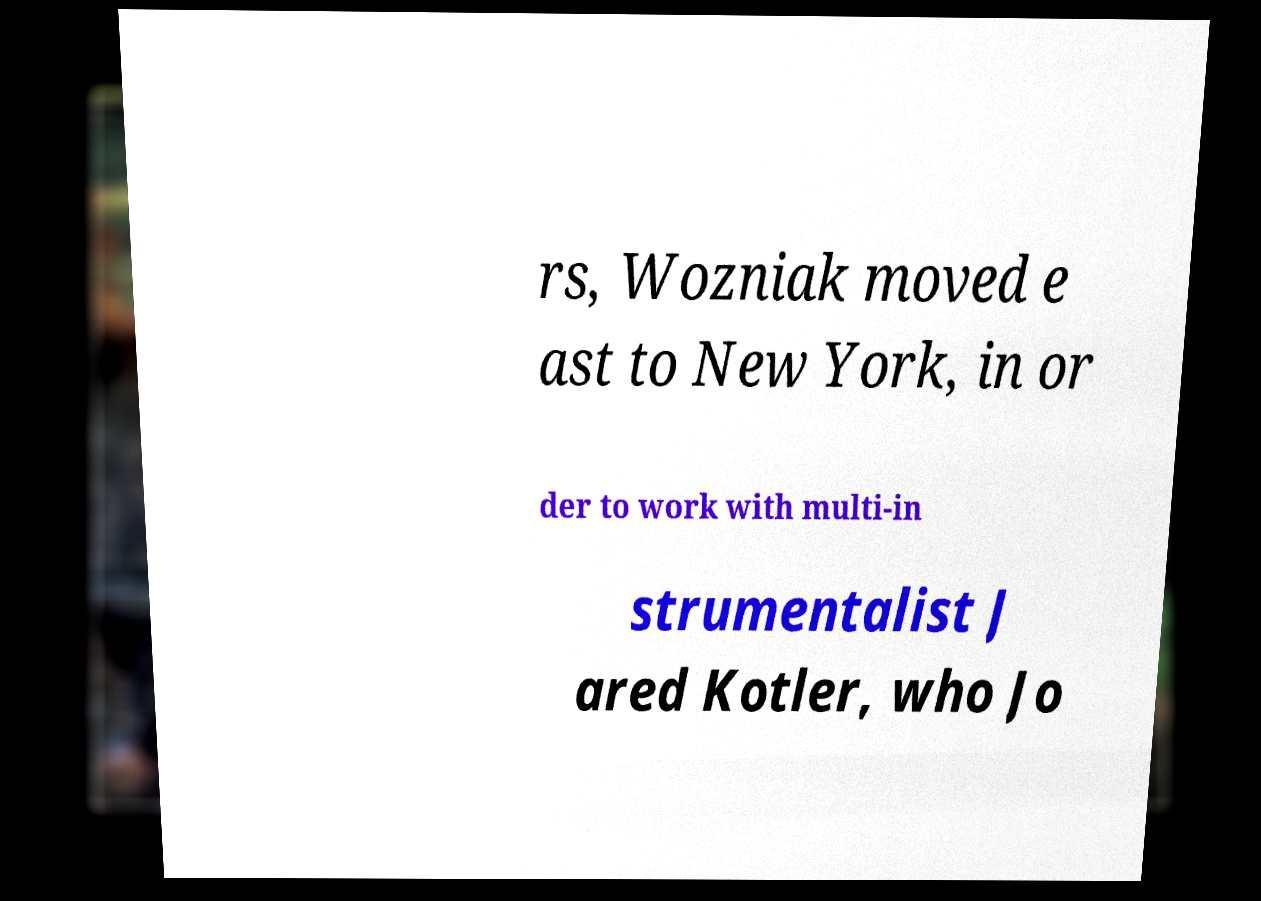Can you read and provide the text displayed in the image?This photo seems to have some interesting text. Can you extract and type it out for me? rs, Wozniak moved e ast to New York, in or der to work with multi-in strumentalist J ared Kotler, who Jo 